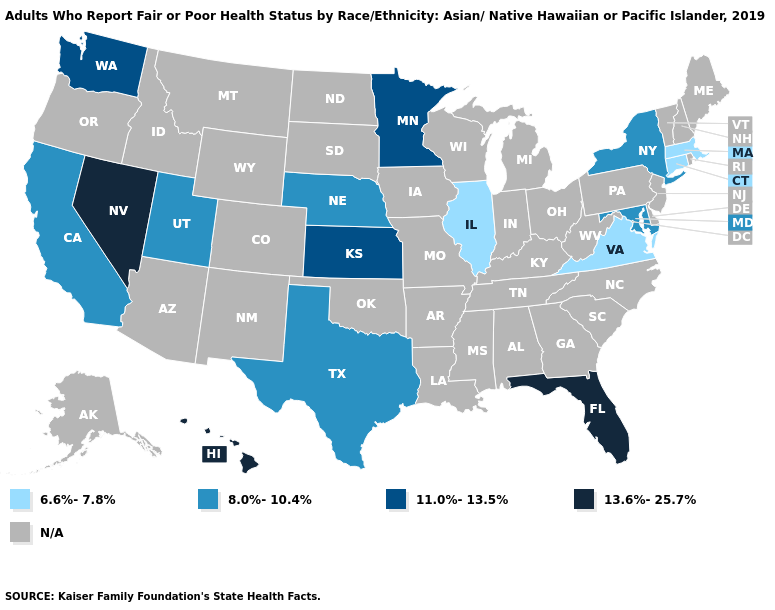Name the states that have a value in the range 6.6%-7.8%?
Short answer required. Connecticut, Illinois, Massachusetts, Virginia. Name the states that have a value in the range 8.0%-10.4%?
Answer briefly. California, Maryland, Nebraska, New York, Texas, Utah. Does Nevada have the lowest value in the USA?
Quick response, please. No. What is the value of New Hampshire?
Quick response, please. N/A. Is the legend a continuous bar?
Concise answer only. No. What is the lowest value in the West?
Keep it brief. 8.0%-10.4%. What is the value of Colorado?
Concise answer only. N/A. Does the first symbol in the legend represent the smallest category?
Keep it brief. Yes. Name the states that have a value in the range 13.6%-25.7%?
Give a very brief answer. Florida, Hawaii, Nevada. Does the first symbol in the legend represent the smallest category?
Be succinct. Yes. Name the states that have a value in the range 11.0%-13.5%?
Answer briefly. Kansas, Minnesota, Washington. Does Illinois have the highest value in the MidWest?
Short answer required. No. What is the value of Virginia?
Write a very short answer. 6.6%-7.8%. Does New York have the lowest value in the Northeast?
Keep it brief. No. 